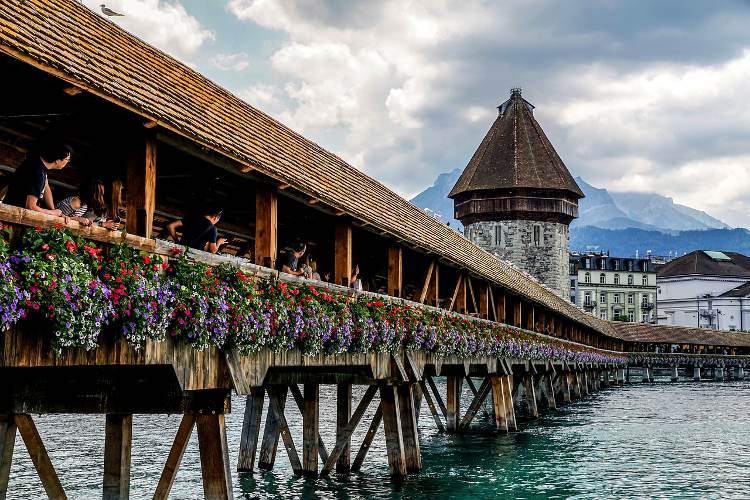What do you think is going on in this snapshot? This image beautifully captures the Chapel Bridge, a historic wooden bridge in Lucerne, Switzerland. The bridge, which spans the Reuss River, is a covered structure adorned with vibrant flowers that add a splash of color to its rustic wooden design. Prominently standing on the right of the bridge is the Wasserturm, or Water Tower, a medieval stone tower that has served various purposes throughout history, including a prison and a treasury. The scene is set against the breathtaking backdrop of the Swiss Alps, with peaks rising majestically under a sky dotted with clouds. This picturesque snapshot offers a glimpse into the charm and historical significance of one of Lucerne's most iconic landmarks. 